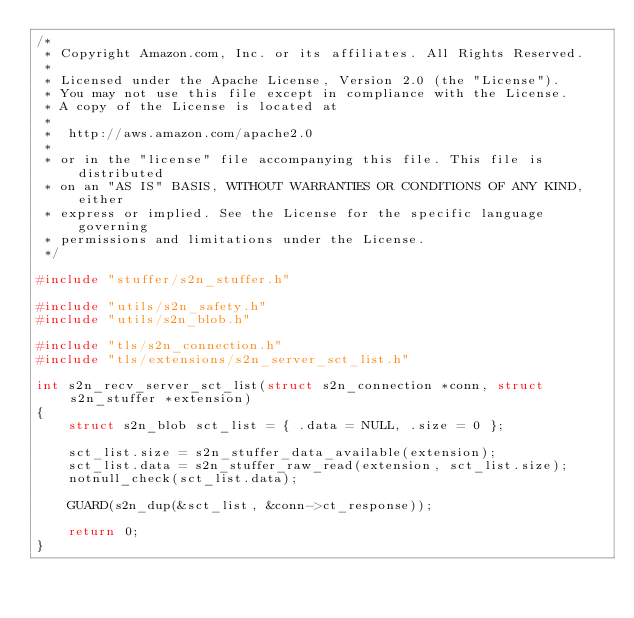<code> <loc_0><loc_0><loc_500><loc_500><_C_>/*
 * Copyright Amazon.com, Inc. or its affiliates. All Rights Reserved.
 *
 * Licensed under the Apache License, Version 2.0 (the "License").
 * You may not use this file except in compliance with the License.
 * A copy of the License is located at
 *
 *  http://aws.amazon.com/apache2.0
 *
 * or in the "license" file accompanying this file. This file is distributed
 * on an "AS IS" BASIS, WITHOUT WARRANTIES OR CONDITIONS OF ANY KIND, either
 * express or implied. See the License for the specific language governing
 * permissions and limitations under the License.
 */

#include "stuffer/s2n_stuffer.h"

#include "utils/s2n_safety.h"
#include "utils/s2n_blob.h"

#include "tls/s2n_connection.h"
#include "tls/extensions/s2n_server_sct_list.h"

int s2n_recv_server_sct_list(struct s2n_connection *conn, struct s2n_stuffer *extension)
{
    struct s2n_blob sct_list = { .data = NULL, .size = 0 };

    sct_list.size = s2n_stuffer_data_available(extension);
    sct_list.data = s2n_stuffer_raw_read(extension, sct_list.size);
    notnull_check(sct_list.data);

    GUARD(s2n_dup(&sct_list, &conn->ct_response));

    return 0;
}
</code> 